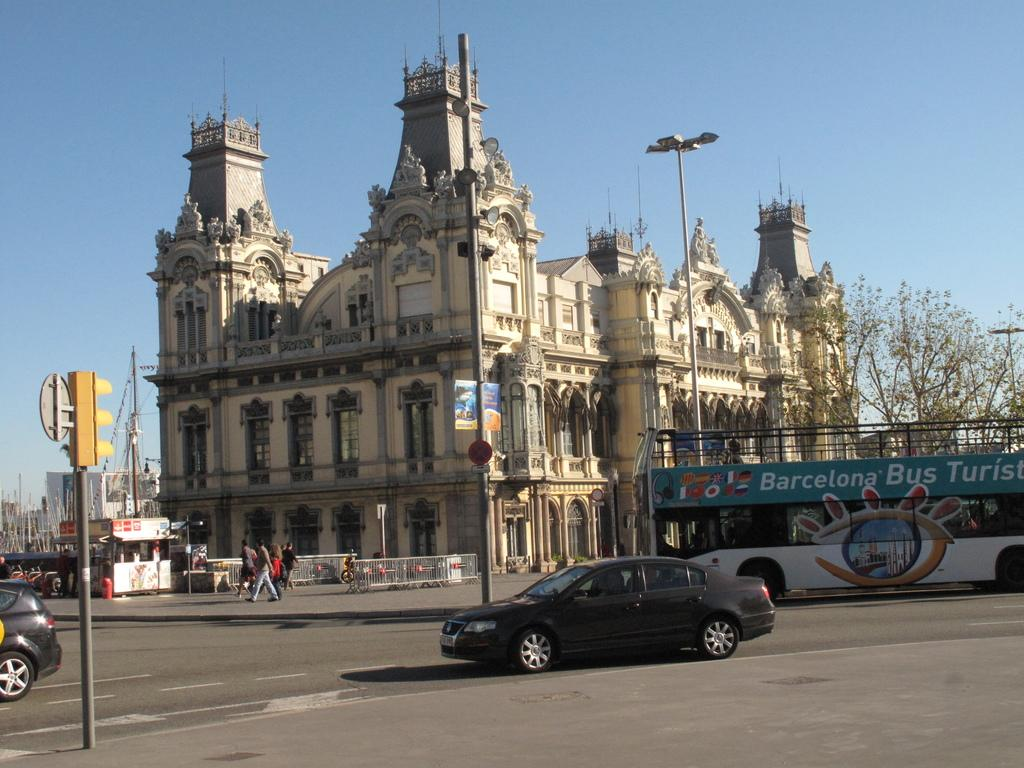What type of structures can be seen in the image? There are buildings in the image. What traffic control devices are present in the image? There are traffic lights in the image. What type of lighting is present along the road in the image? There are street lights in the image. What type of transportation is visible on the road in the image? There are vehicles on the road in the image. What type of barrier is present in the image? There is a fence in the image. What other objects can be seen in the image? There are other objects in the image, but their specific details are not mentioned in the provided facts. What can be seen in the background of the image? The sky is visible in the background of the image. How much blood can be seen on the vehicles in the image? There is no mention of blood in the image, so it cannot be determined from the provided facts. What type of property is being sold in the image? There is no indication of any property being sold in the image. How many passengers are visible in the vehicles in the image? The number of passengers in the vehicles is not mentioned in the provided facts, so it cannot be determined from the image. 